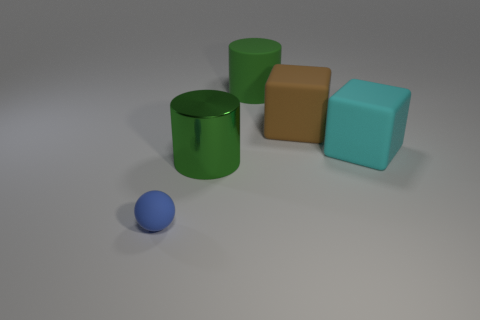There is another cylinder that is the same color as the large rubber cylinder; what is its material?
Provide a short and direct response. Metal. There is a cylinder that is to the right of the big green shiny cylinder; does it have the same color as the metallic thing?
Your response must be concise. Yes. Is there a big gray rubber object that has the same shape as the big green metal thing?
Offer a terse response. No. There is a green cylinder that is behind the brown block; does it have the same size as the tiny blue rubber sphere?
Give a very brief answer. No. What size is the rubber thing that is in front of the big brown block and to the right of the big green shiny object?
Your response must be concise. Large. How many other things are the same material as the blue ball?
Ensure brevity in your answer.  3. What is the size of the cube that is in front of the brown matte thing?
Your answer should be very brief. Large. Is the big metallic thing the same color as the rubber cylinder?
Your response must be concise. Yes. How many large things are cyan matte objects or red shiny blocks?
Make the answer very short. 1. Are there any other things that are the same color as the sphere?
Make the answer very short. No. 